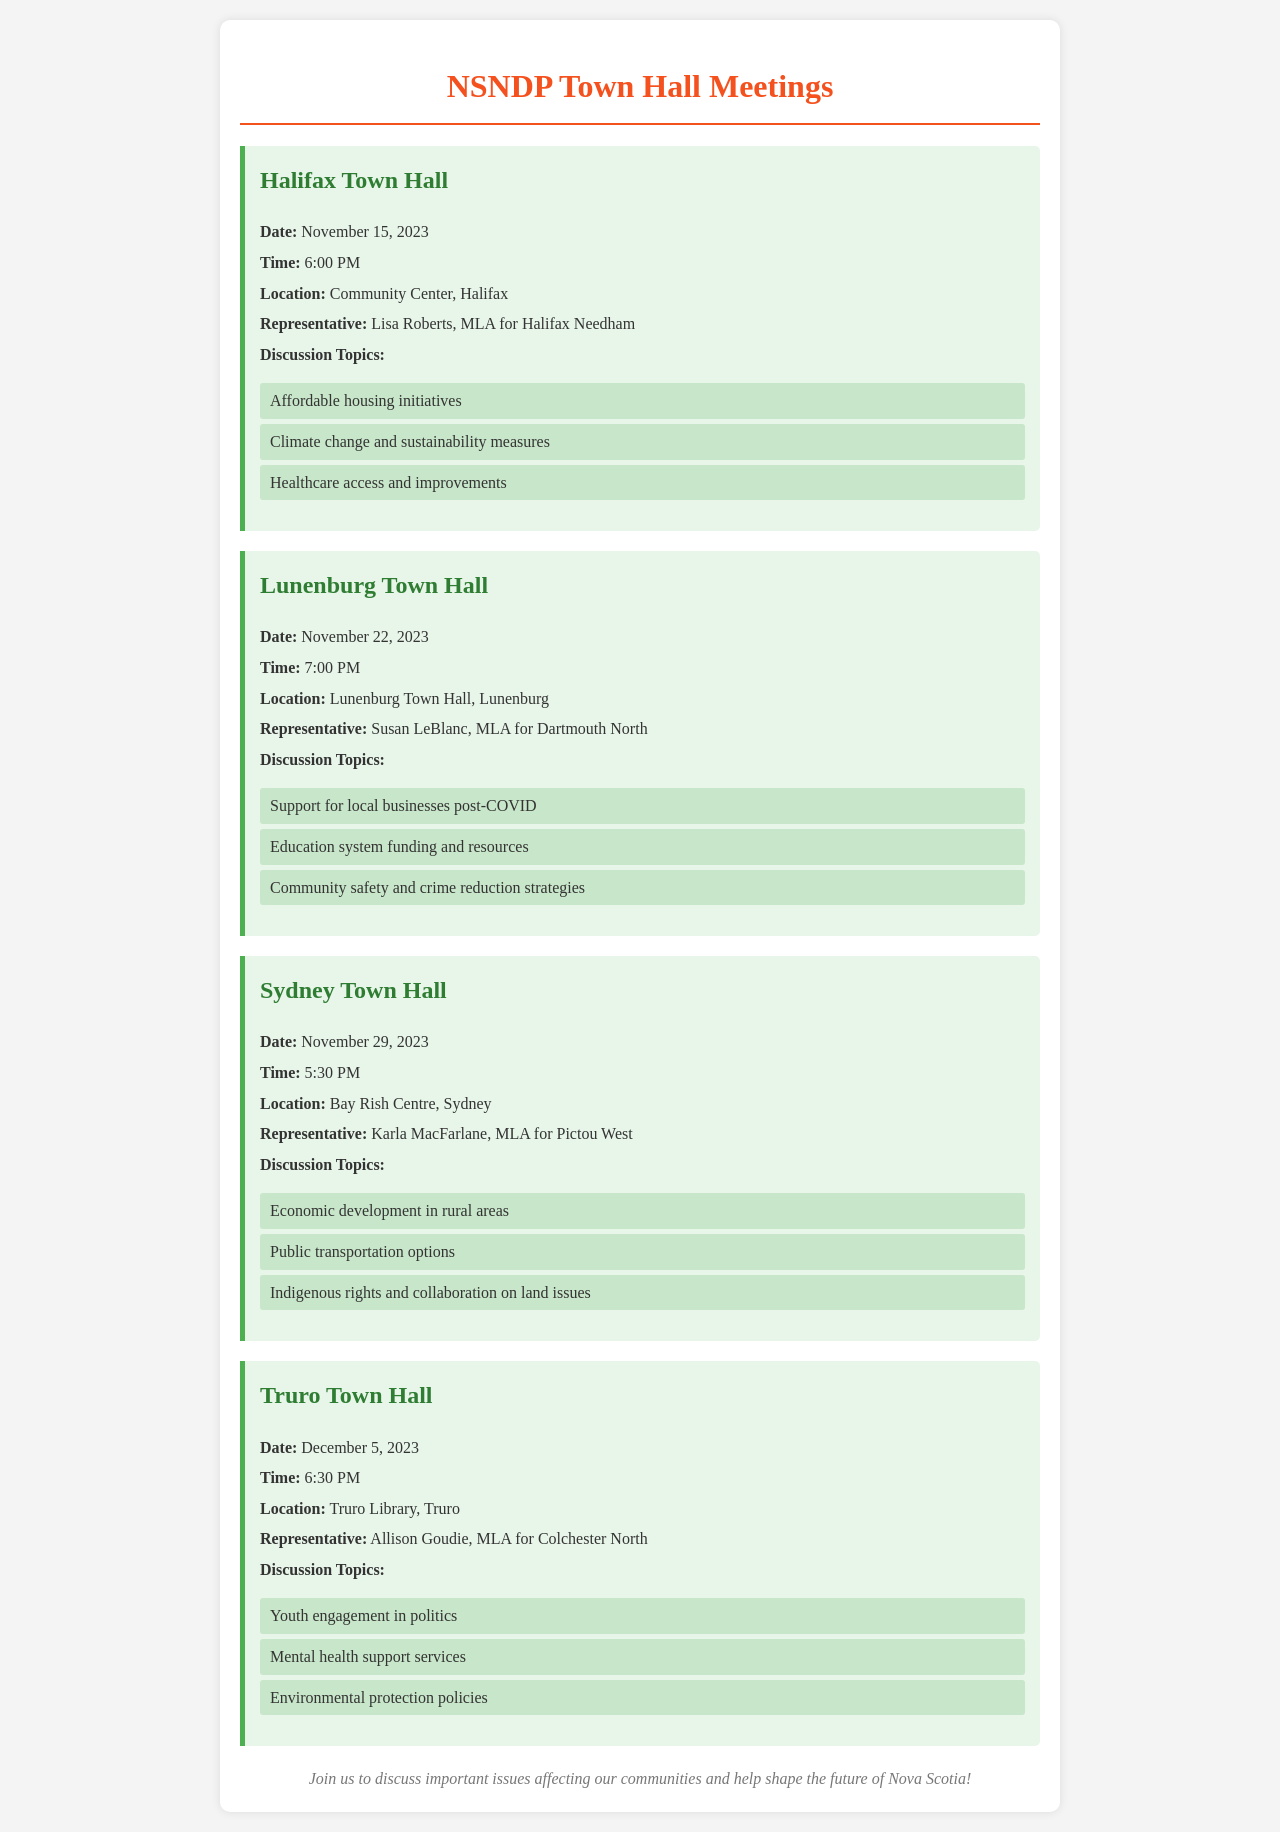What is the date of the Halifax Town Hall? The date of the Halifax Town Hall is explicitly mentioned in the document, which states it will take place on November 15, 2023.
Answer: November 15, 2023 Who is the representative for the Lunenburg Town Hall? The document specifies that the representative for the Lunenburg Town Hall is Susan LeBlanc, MLA for Dartmouth North.
Answer: Susan LeBlanc What time does the Sydney Town Hall meeting start? According to the schedule, the Sydney Town Hall meeting starts at 5:30 PM.
Answer: 5:30 PM Which topic will be discussed at the Truro Town Hall? The document lists several discussion topics for the Truro Town Hall, including youth engagement in politics, making it a suitable example for this question.
Answer: Youth engagement in politics What is the venue for the Lunenburg Town Hall meeting? The document clearly states the location of the Lunenburg Town Hall meetings as Lunenburg Town Hall, Lunenburg.
Answer: Lunenburg Town Hall How many town hall meetings are listed in the document? The document includes details for four distinct town hall meetings, which allows us to determine the total number efficiently.
Answer: Four What are some key topics being discussed at the Halifax Town Hall? The Halifax Town Hall is set to cover important issues, including affordable housing initiatives, making it a key discussion point.
Answer: Affordable housing initiatives What is unique about the Sydney Town Hall meeting's discussion topics compared to others? The focus on Indigenous rights and collaboration on land issues sets the Sydney Town Hall apart from the other meetings discussed in the document.
Answer: Indigenous rights and collaboration on land issues 